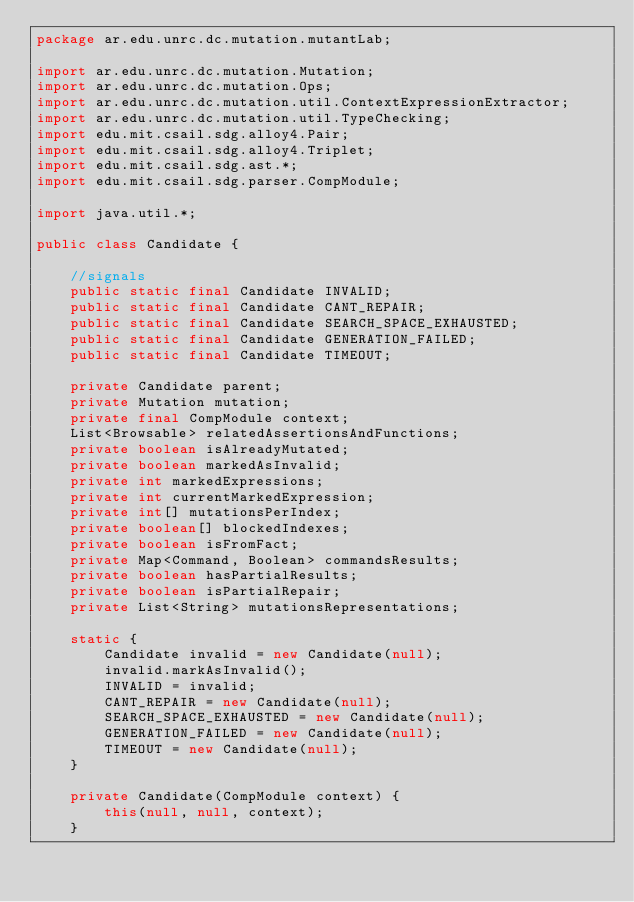<code> <loc_0><loc_0><loc_500><loc_500><_Java_>package ar.edu.unrc.dc.mutation.mutantLab;

import ar.edu.unrc.dc.mutation.Mutation;
import ar.edu.unrc.dc.mutation.Ops;
import ar.edu.unrc.dc.mutation.util.ContextExpressionExtractor;
import ar.edu.unrc.dc.mutation.util.TypeChecking;
import edu.mit.csail.sdg.alloy4.Pair;
import edu.mit.csail.sdg.alloy4.Triplet;
import edu.mit.csail.sdg.ast.*;
import edu.mit.csail.sdg.parser.CompModule;

import java.util.*;

public class Candidate {

    //signals
    public static final Candidate INVALID;
    public static final Candidate CANT_REPAIR;
    public static final Candidate SEARCH_SPACE_EXHAUSTED;
    public static final Candidate GENERATION_FAILED;
    public static final Candidate TIMEOUT;

    private Candidate parent;
    private Mutation mutation;
    private final CompModule context;
    List<Browsable> relatedAssertionsAndFunctions;
    private boolean isAlreadyMutated;
    private boolean markedAsInvalid;
    private int markedExpressions;
    private int currentMarkedExpression;
    private int[] mutationsPerIndex;
    private boolean[] blockedIndexes;
    private boolean isFromFact;
    private Map<Command, Boolean> commandsResults;
    private boolean hasPartialResults;
    private boolean isPartialRepair;
    private List<String> mutationsRepresentations;

    static {
        Candidate invalid = new Candidate(null);
        invalid.markAsInvalid();
        INVALID = invalid;
        CANT_REPAIR = new Candidate(null);
        SEARCH_SPACE_EXHAUSTED = new Candidate(null);
        GENERATION_FAILED = new Candidate(null);
        TIMEOUT = new Candidate(null);
    }

    private Candidate(CompModule context) {
        this(null, null, context);
    }
</code> 